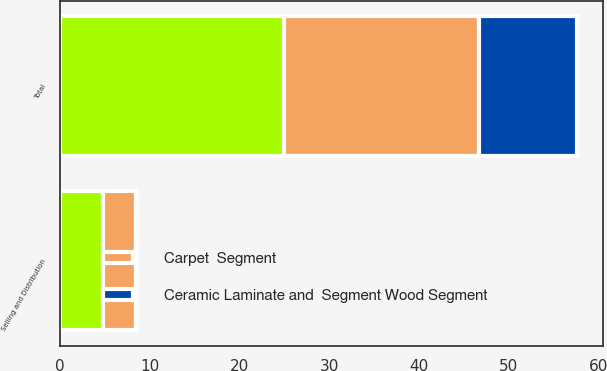Convert chart to OTSL. <chart><loc_0><loc_0><loc_500><loc_500><stacked_bar_chart><ecel><fcel>Selling and Distribution<fcel>Total<nl><fcel>Carpet  Segment<fcel>3.7<fcel>21.7<nl><fcel>nan<fcel>4.8<fcel>25<nl><fcel>Ceramic Laminate and  Segment Wood Segment<fcel>0.1<fcel>10.9<nl></chart> 